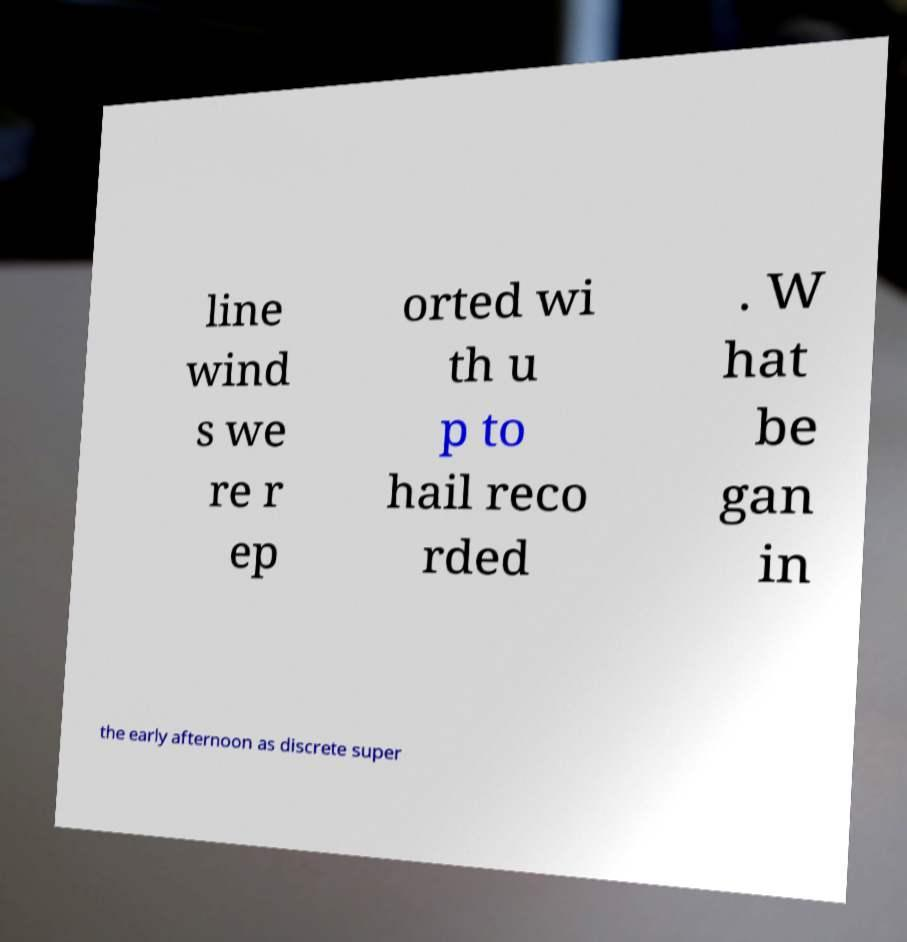Can you accurately transcribe the text from the provided image for me? line wind s we re r ep orted wi th u p to hail reco rded . W hat be gan in the early afternoon as discrete super 